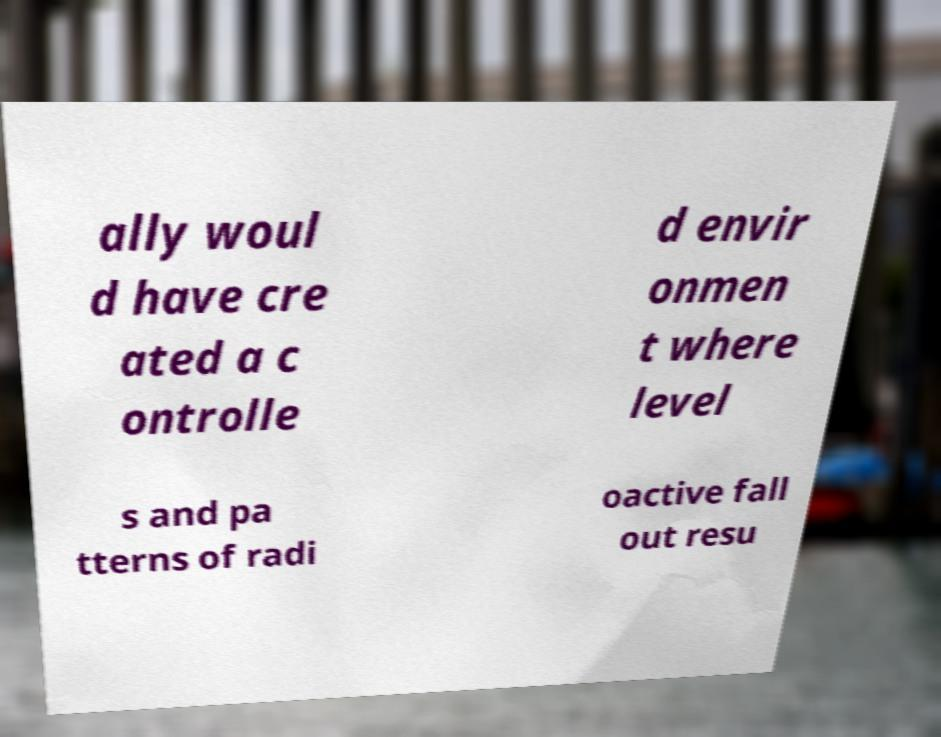What messages or text are displayed in this image? I need them in a readable, typed format. ally woul d have cre ated a c ontrolle d envir onmen t where level s and pa tterns of radi oactive fall out resu 